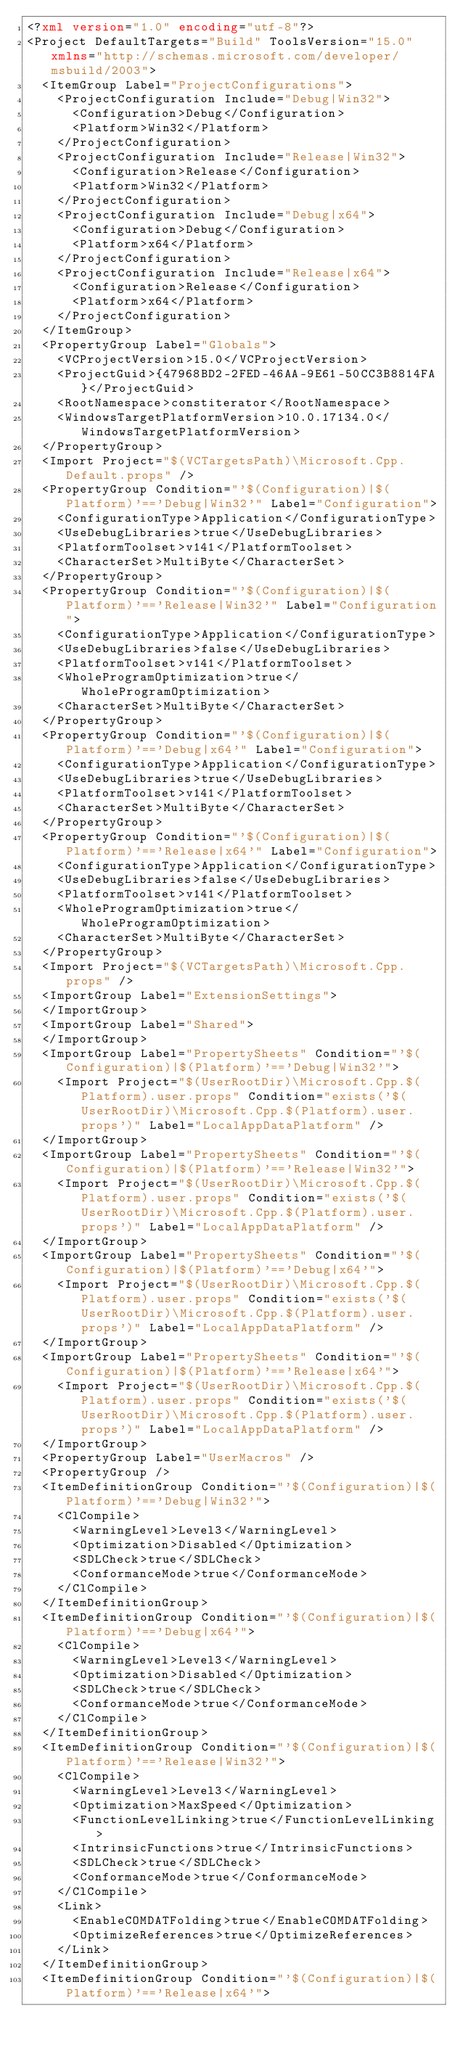<code> <loc_0><loc_0><loc_500><loc_500><_XML_><?xml version="1.0" encoding="utf-8"?>
<Project DefaultTargets="Build" ToolsVersion="15.0" xmlns="http://schemas.microsoft.com/developer/msbuild/2003">
  <ItemGroup Label="ProjectConfigurations">
    <ProjectConfiguration Include="Debug|Win32">
      <Configuration>Debug</Configuration>
      <Platform>Win32</Platform>
    </ProjectConfiguration>
    <ProjectConfiguration Include="Release|Win32">
      <Configuration>Release</Configuration>
      <Platform>Win32</Platform>
    </ProjectConfiguration>
    <ProjectConfiguration Include="Debug|x64">
      <Configuration>Debug</Configuration>
      <Platform>x64</Platform>
    </ProjectConfiguration>
    <ProjectConfiguration Include="Release|x64">
      <Configuration>Release</Configuration>
      <Platform>x64</Platform>
    </ProjectConfiguration>
  </ItemGroup>
  <PropertyGroup Label="Globals">
    <VCProjectVersion>15.0</VCProjectVersion>
    <ProjectGuid>{47968BD2-2FED-46AA-9E61-50CC3B8814FA}</ProjectGuid>
    <RootNamespace>constiterator</RootNamespace>
    <WindowsTargetPlatformVersion>10.0.17134.0</WindowsTargetPlatformVersion>
  </PropertyGroup>
  <Import Project="$(VCTargetsPath)\Microsoft.Cpp.Default.props" />
  <PropertyGroup Condition="'$(Configuration)|$(Platform)'=='Debug|Win32'" Label="Configuration">
    <ConfigurationType>Application</ConfigurationType>
    <UseDebugLibraries>true</UseDebugLibraries>
    <PlatformToolset>v141</PlatformToolset>
    <CharacterSet>MultiByte</CharacterSet>
  </PropertyGroup>
  <PropertyGroup Condition="'$(Configuration)|$(Platform)'=='Release|Win32'" Label="Configuration">
    <ConfigurationType>Application</ConfigurationType>
    <UseDebugLibraries>false</UseDebugLibraries>
    <PlatformToolset>v141</PlatformToolset>
    <WholeProgramOptimization>true</WholeProgramOptimization>
    <CharacterSet>MultiByte</CharacterSet>
  </PropertyGroup>
  <PropertyGroup Condition="'$(Configuration)|$(Platform)'=='Debug|x64'" Label="Configuration">
    <ConfigurationType>Application</ConfigurationType>
    <UseDebugLibraries>true</UseDebugLibraries>
    <PlatformToolset>v141</PlatformToolset>
    <CharacterSet>MultiByte</CharacterSet>
  </PropertyGroup>
  <PropertyGroup Condition="'$(Configuration)|$(Platform)'=='Release|x64'" Label="Configuration">
    <ConfigurationType>Application</ConfigurationType>
    <UseDebugLibraries>false</UseDebugLibraries>
    <PlatformToolset>v141</PlatformToolset>
    <WholeProgramOptimization>true</WholeProgramOptimization>
    <CharacterSet>MultiByte</CharacterSet>
  </PropertyGroup>
  <Import Project="$(VCTargetsPath)\Microsoft.Cpp.props" />
  <ImportGroup Label="ExtensionSettings">
  </ImportGroup>
  <ImportGroup Label="Shared">
  </ImportGroup>
  <ImportGroup Label="PropertySheets" Condition="'$(Configuration)|$(Platform)'=='Debug|Win32'">
    <Import Project="$(UserRootDir)\Microsoft.Cpp.$(Platform).user.props" Condition="exists('$(UserRootDir)\Microsoft.Cpp.$(Platform).user.props')" Label="LocalAppDataPlatform" />
  </ImportGroup>
  <ImportGroup Label="PropertySheets" Condition="'$(Configuration)|$(Platform)'=='Release|Win32'">
    <Import Project="$(UserRootDir)\Microsoft.Cpp.$(Platform).user.props" Condition="exists('$(UserRootDir)\Microsoft.Cpp.$(Platform).user.props')" Label="LocalAppDataPlatform" />
  </ImportGroup>
  <ImportGroup Label="PropertySheets" Condition="'$(Configuration)|$(Platform)'=='Debug|x64'">
    <Import Project="$(UserRootDir)\Microsoft.Cpp.$(Platform).user.props" Condition="exists('$(UserRootDir)\Microsoft.Cpp.$(Platform).user.props')" Label="LocalAppDataPlatform" />
  </ImportGroup>
  <ImportGroup Label="PropertySheets" Condition="'$(Configuration)|$(Platform)'=='Release|x64'">
    <Import Project="$(UserRootDir)\Microsoft.Cpp.$(Platform).user.props" Condition="exists('$(UserRootDir)\Microsoft.Cpp.$(Platform).user.props')" Label="LocalAppDataPlatform" />
  </ImportGroup>
  <PropertyGroup Label="UserMacros" />
  <PropertyGroup />
  <ItemDefinitionGroup Condition="'$(Configuration)|$(Platform)'=='Debug|Win32'">
    <ClCompile>
      <WarningLevel>Level3</WarningLevel>
      <Optimization>Disabled</Optimization>
      <SDLCheck>true</SDLCheck>
      <ConformanceMode>true</ConformanceMode>
    </ClCompile>
  </ItemDefinitionGroup>
  <ItemDefinitionGroup Condition="'$(Configuration)|$(Platform)'=='Debug|x64'">
    <ClCompile>
      <WarningLevel>Level3</WarningLevel>
      <Optimization>Disabled</Optimization>
      <SDLCheck>true</SDLCheck>
      <ConformanceMode>true</ConformanceMode>
    </ClCompile>
  </ItemDefinitionGroup>
  <ItemDefinitionGroup Condition="'$(Configuration)|$(Platform)'=='Release|Win32'">
    <ClCompile>
      <WarningLevel>Level3</WarningLevel>
      <Optimization>MaxSpeed</Optimization>
      <FunctionLevelLinking>true</FunctionLevelLinking>
      <IntrinsicFunctions>true</IntrinsicFunctions>
      <SDLCheck>true</SDLCheck>
      <ConformanceMode>true</ConformanceMode>
    </ClCompile>
    <Link>
      <EnableCOMDATFolding>true</EnableCOMDATFolding>
      <OptimizeReferences>true</OptimizeReferences>
    </Link>
  </ItemDefinitionGroup>
  <ItemDefinitionGroup Condition="'$(Configuration)|$(Platform)'=='Release|x64'"></code> 